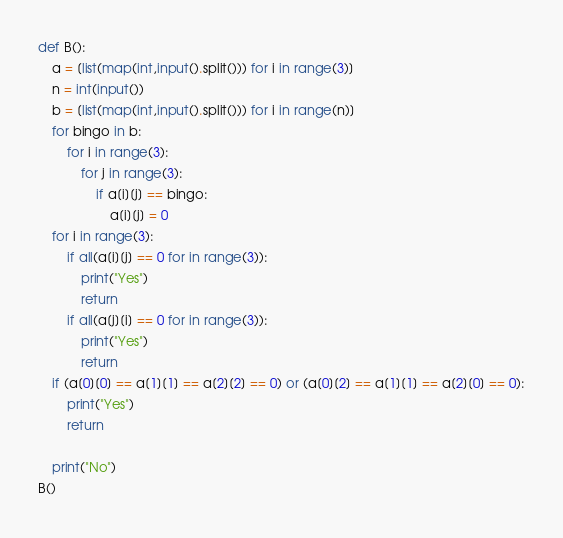<code> <loc_0><loc_0><loc_500><loc_500><_Python_>def B():
    a = [list(map(int,input().split())) for i in range(3)]
    n = int(input())
    b = [list(map(int,input().split())) for i in range(n)]
    for bingo in b:
        for i in range(3):
            for j in range(3):
                if a[i][j] == bingo:
                    a[i][j] = 0
    for i in range(3):
        if all(a[i][j] == 0 for in range(3)):
            print("Yes")
            return
        if all(a[j][i] == 0 for in range(3)):
            print("Yes")
            return
    if (a[0][0] == a[1][1] == a[2][2] == 0) or (a[0][2] == a[1][1] == a[2][0] == 0):
        print("Yes")
        return

    print("No")
B()</code> 